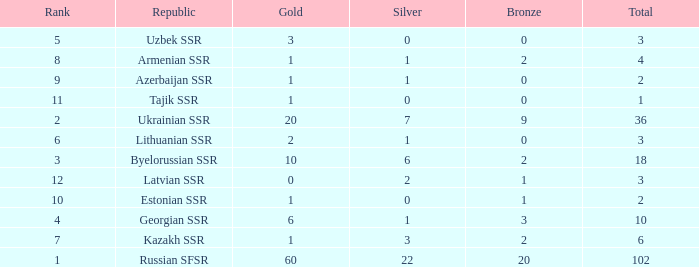Would you mind parsing the complete table? {'header': ['Rank', 'Republic', 'Gold', 'Silver', 'Bronze', 'Total'], 'rows': [['5', 'Uzbek SSR', '3', '0', '0', '3'], ['8', 'Armenian SSR', '1', '1', '2', '4'], ['9', 'Azerbaijan SSR', '1', '1', '0', '2'], ['11', 'Tajik SSR', '1', '0', '0', '1'], ['2', 'Ukrainian SSR', '20', '7', '9', '36'], ['6', 'Lithuanian SSR', '2', '1', '0', '3'], ['3', 'Byelorussian SSR', '10', '6', '2', '18'], ['12', 'Latvian SSR', '0', '2', '1', '3'], ['10', 'Estonian SSR', '1', '0', '1', '2'], ['4', 'Georgian SSR', '6', '1', '3', '10'], ['7', 'Kazakh SSR', '1', '3', '2', '6'], ['1', 'Russian SFSR', '60', '22', '20', '102']]} What is the sum of bronzes for teams with more than 2 gold, ranked under 3, and less than 22 silver? 9.0. 